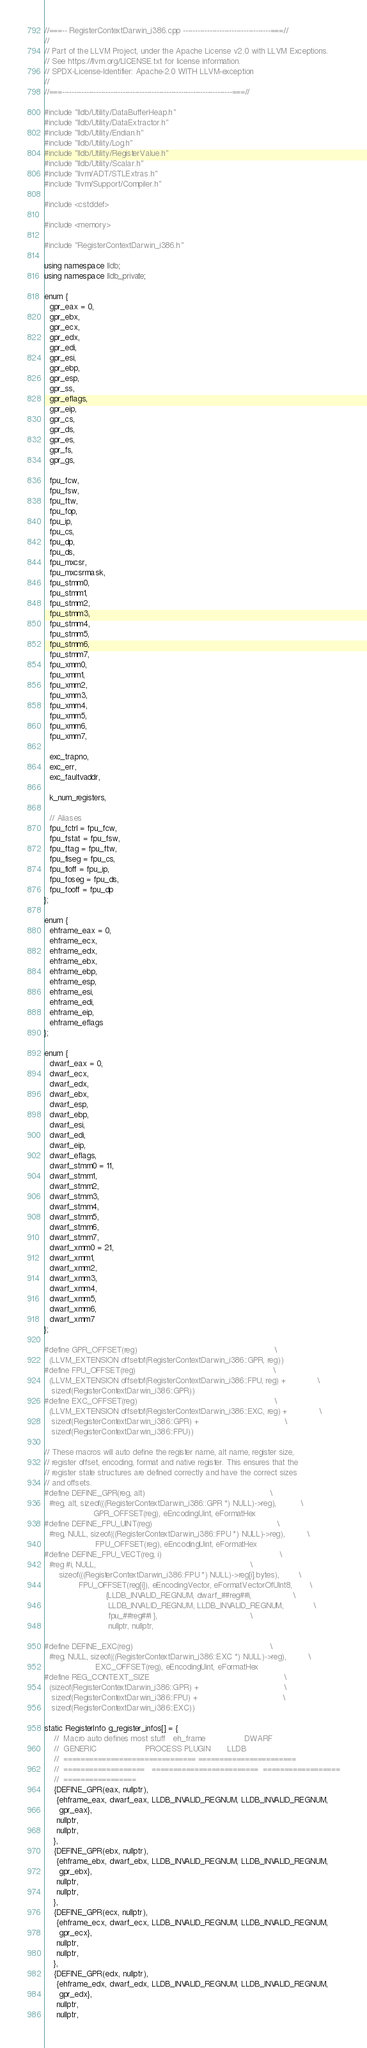Convert code to text. <code><loc_0><loc_0><loc_500><loc_500><_C++_>//===-- RegisterContextDarwin_i386.cpp ------------------------------------===//
//
// Part of the LLVM Project, under the Apache License v2.0 with LLVM Exceptions.
// See https://llvm.org/LICENSE.txt for license information.
// SPDX-License-Identifier: Apache-2.0 WITH LLVM-exception
//
//===----------------------------------------------------------------------===//

#include "lldb/Utility/DataBufferHeap.h"
#include "lldb/Utility/DataExtractor.h"
#include "lldb/Utility/Endian.h"
#include "lldb/Utility/Log.h"
#include "lldb/Utility/RegisterValue.h"
#include "lldb/Utility/Scalar.h"
#include "llvm/ADT/STLExtras.h"
#include "llvm/Support/Compiler.h"

#include <cstddef>

#include <memory>

#include "RegisterContextDarwin_i386.h"

using namespace lldb;
using namespace lldb_private;

enum {
  gpr_eax = 0,
  gpr_ebx,
  gpr_ecx,
  gpr_edx,
  gpr_edi,
  gpr_esi,
  gpr_ebp,
  gpr_esp,
  gpr_ss,
  gpr_eflags,
  gpr_eip,
  gpr_cs,
  gpr_ds,
  gpr_es,
  gpr_fs,
  gpr_gs,

  fpu_fcw,
  fpu_fsw,
  fpu_ftw,
  fpu_fop,
  fpu_ip,
  fpu_cs,
  fpu_dp,
  fpu_ds,
  fpu_mxcsr,
  fpu_mxcsrmask,
  fpu_stmm0,
  fpu_stmm1,
  fpu_stmm2,
  fpu_stmm3,
  fpu_stmm4,
  fpu_stmm5,
  fpu_stmm6,
  fpu_stmm7,
  fpu_xmm0,
  fpu_xmm1,
  fpu_xmm2,
  fpu_xmm3,
  fpu_xmm4,
  fpu_xmm5,
  fpu_xmm6,
  fpu_xmm7,

  exc_trapno,
  exc_err,
  exc_faultvaddr,

  k_num_registers,

  // Aliases
  fpu_fctrl = fpu_fcw,
  fpu_fstat = fpu_fsw,
  fpu_ftag = fpu_ftw,
  fpu_fiseg = fpu_cs,
  fpu_fioff = fpu_ip,
  fpu_foseg = fpu_ds,
  fpu_fooff = fpu_dp
};

enum {
  ehframe_eax = 0,
  ehframe_ecx,
  ehframe_edx,
  ehframe_ebx,
  ehframe_ebp,
  ehframe_esp,
  ehframe_esi,
  ehframe_edi,
  ehframe_eip,
  ehframe_eflags
};

enum {
  dwarf_eax = 0,
  dwarf_ecx,
  dwarf_edx,
  dwarf_ebx,
  dwarf_esp,
  dwarf_ebp,
  dwarf_esi,
  dwarf_edi,
  dwarf_eip,
  dwarf_eflags,
  dwarf_stmm0 = 11,
  dwarf_stmm1,
  dwarf_stmm2,
  dwarf_stmm3,
  dwarf_stmm4,
  dwarf_stmm5,
  dwarf_stmm6,
  dwarf_stmm7,
  dwarf_xmm0 = 21,
  dwarf_xmm1,
  dwarf_xmm2,
  dwarf_xmm3,
  dwarf_xmm4,
  dwarf_xmm5,
  dwarf_xmm6,
  dwarf_xmm7
};

#define GPR_OFFSET(reg)                                                        \
  (LLVM_EXTENSION offsetof(RegisterContextDarwin_i386::GPR, reg))
#define FPU_OFFSET(reg)                                                        \
  (LLVM_EXTENSION offsetof(RegisterContextDarwin_i386::FPU, reg) +             \
   sizeof(RegisterContextDarwin_i386::GPR))
#define EXC_OFFSET(reg)                                                        \
  (LLVM_EXTENSION offsetof(RegisterContextDarwin_i386::EXC, reg) +             \
   sizeof(RegisterContextDarwin_i386::GPR) +                                   \
   sizeof(RegisterContextDarwin_i386::FPU))

// These macros will auto define the register name, alt name, register size,
// register offset, encoding, format and native register. This ensures that the
// register state structures are defined correctly and have the correct sizes
// and offsets.
#define DEFINE_GPR(reg, alt)                                                   \
  #reg, alt, sizeof(((RegisterContextDarwin_i386::GPR *) NULL)->reg),          \
                    GPR_OFFSET(reg), eEncodingUint, eFormatHex
#define DEFINE_FPU_UINT(reg)                                                   \
  #reg, NULL, sizeof(((RegisterContextDarwin_i386::FPU *) NULL)->reg),         \
                     FPU_OFFSET(reg), eEncodingUint, eFormatHex
#define DEFINE_FPU_VECT(reg, i)                                                \
  #reg #i, NULL,                                                               \
      sizeof(((RegisterContextDarwin_i386::FPU *) NULL)->reg[i].bytes),        \
              FPU_OFFSET(reg[i]), eEncodingVector, eFormatVectorOfUInt8,       \
                         {LLDB_INVALID_REGNUM, dwarf_##reg##i,                 \
                          LLDB_INVALID_REGNUM, LLDB_INVALID_REGNUM,            \
                          fpu_##reg##i },                                      \
                          nullptr, nullptr,

#define DEFINE_EXC(reg)                                                        \
  #reg, NULL, sizeof(((RegisterContextDarwin_i386::EXC *) NULL)->reg),         \
                     EXC_OFFSET(reg), eEncodingUint, eFormatHex
#define REG_CONTEXT_SIZE                                                       \
  (sizeof(RegisterContextDarwin_i386::GPR) +                                   \
   sizeof(RegisterContextDarwin_i386::FPU) +                                   \
   sizeof(RegisterContextDarwin_i386::EXC))

static RegisterInfo g_register_infos[] = {
    //  Macro auto defines most stuff   eh_frame                DWARF
    //  GENERIC                    PROCESS PLUGIN       LLDB
    //  =============================== =======================
    //  ===================   =========================  ==================
    //  =================
    {DEFINE_GPR(eax, nullptr),
     {ehframe_eax, dwarf_eax, LLDB_INVALID_REGNUM, LLDB_INVALID_REGNUM,
      gpr_eax},
     nullptr,
     nullptr,
    },
    {DEFINE_GPR(ebx, nullptr),
     {ehframe_ebx, dwarf_ebx, LLDB_INVALID_REGNUM, LLDB_INVALID_REGNUM,
      gpr_ebx},
     nullptr,
     nullptr,
    },
    {DEFINE_GPR(ecx, nullptr),
     {ehframe_ecx, dwarf_ecx, LLDB_INVALID_REGNUM, LLDB_INVALID_REGNUM,
      gpr_ecx},
     nullptr,
     nullptr,
    },
    {DEFINE_GPR(edx, nullptr),
     {ehframe_edx, dwarf_edx, LLDB_INVALID_REGNUM, LLDB_INVALID_REGNUM,
      gpr_edx},
     nullptr,
     nullptr,</code> 